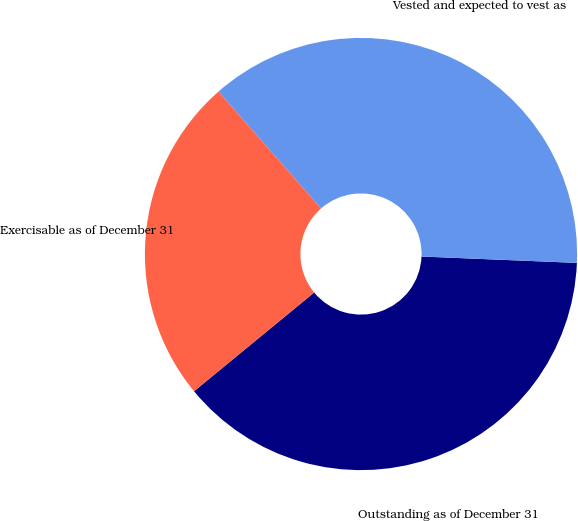Convert chart to OTSL. <chart><loc_0><loc_0><loc_500><loc_500><pie_chart><fcel>Outstanding as of December 31<fcel>Vested and expected to vest as<fcel>Exercisable as of December 31<nl><fcel>38.4%<fcel>37.12%<fcel>24.49%<nl></chart> 